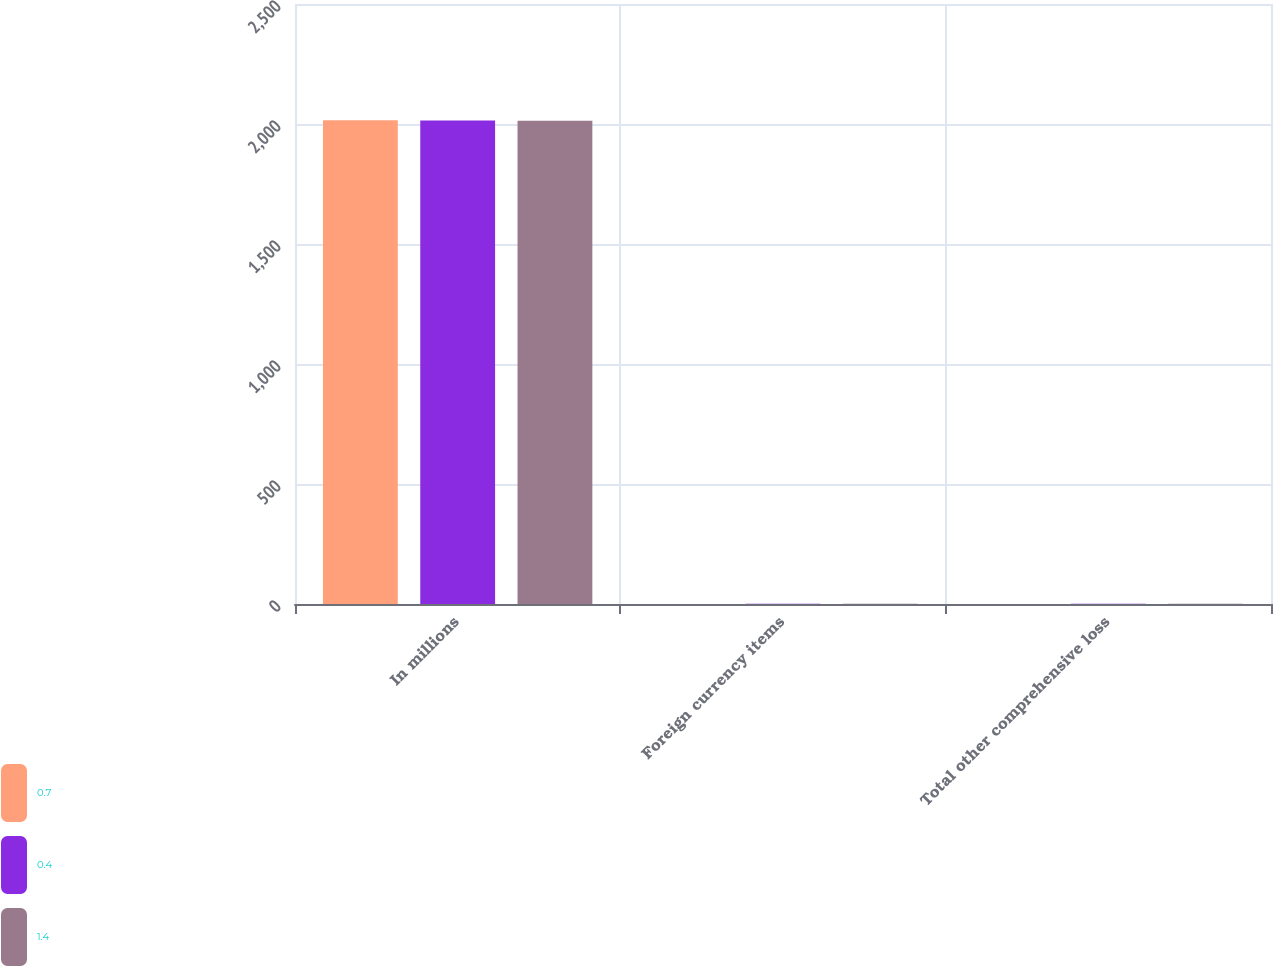Convert chart. <chart><loc_0><loc_0><loc_500><loc_500><stacked_bar_chart><ecel><fcel>In millions<fcel>Foreign currency items<fcel>Total other comprehensive loss<nl><fcel>0.7<fcel>2016<fcel>0.4<fcel>0.4<nl><fcel>0.4<fcel>2015<fcel>1.4<fcel>1.4<nl><fcel>1.4<fcel>2014<fcel>0.7<fcel>0.7<nl></chart> 